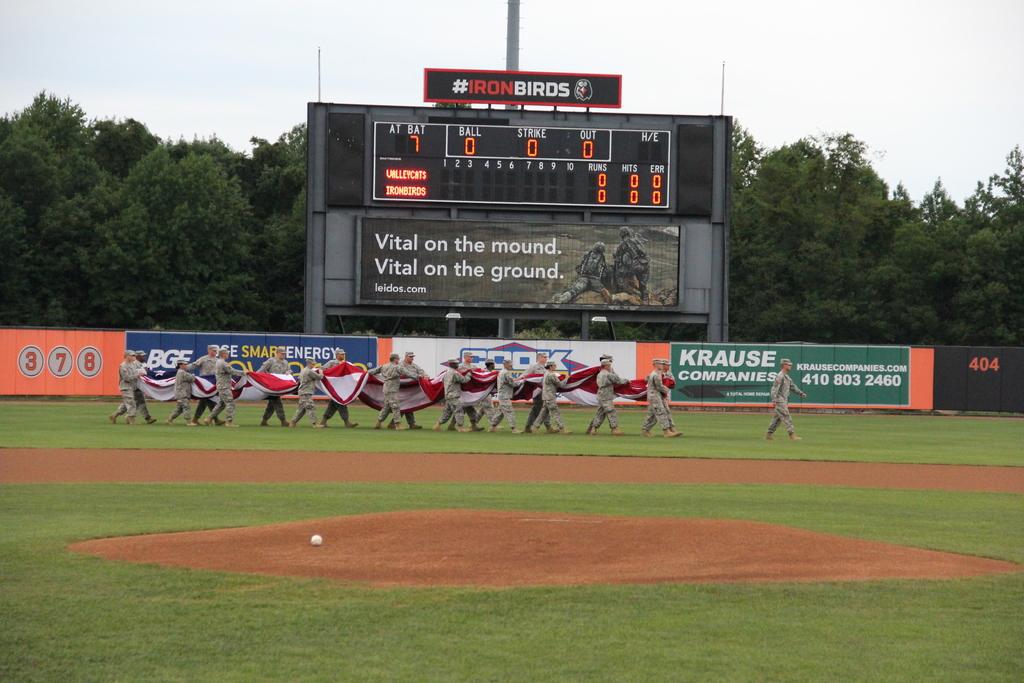What company is advertising on the green banner?
Your answer should be compact. Krause. 